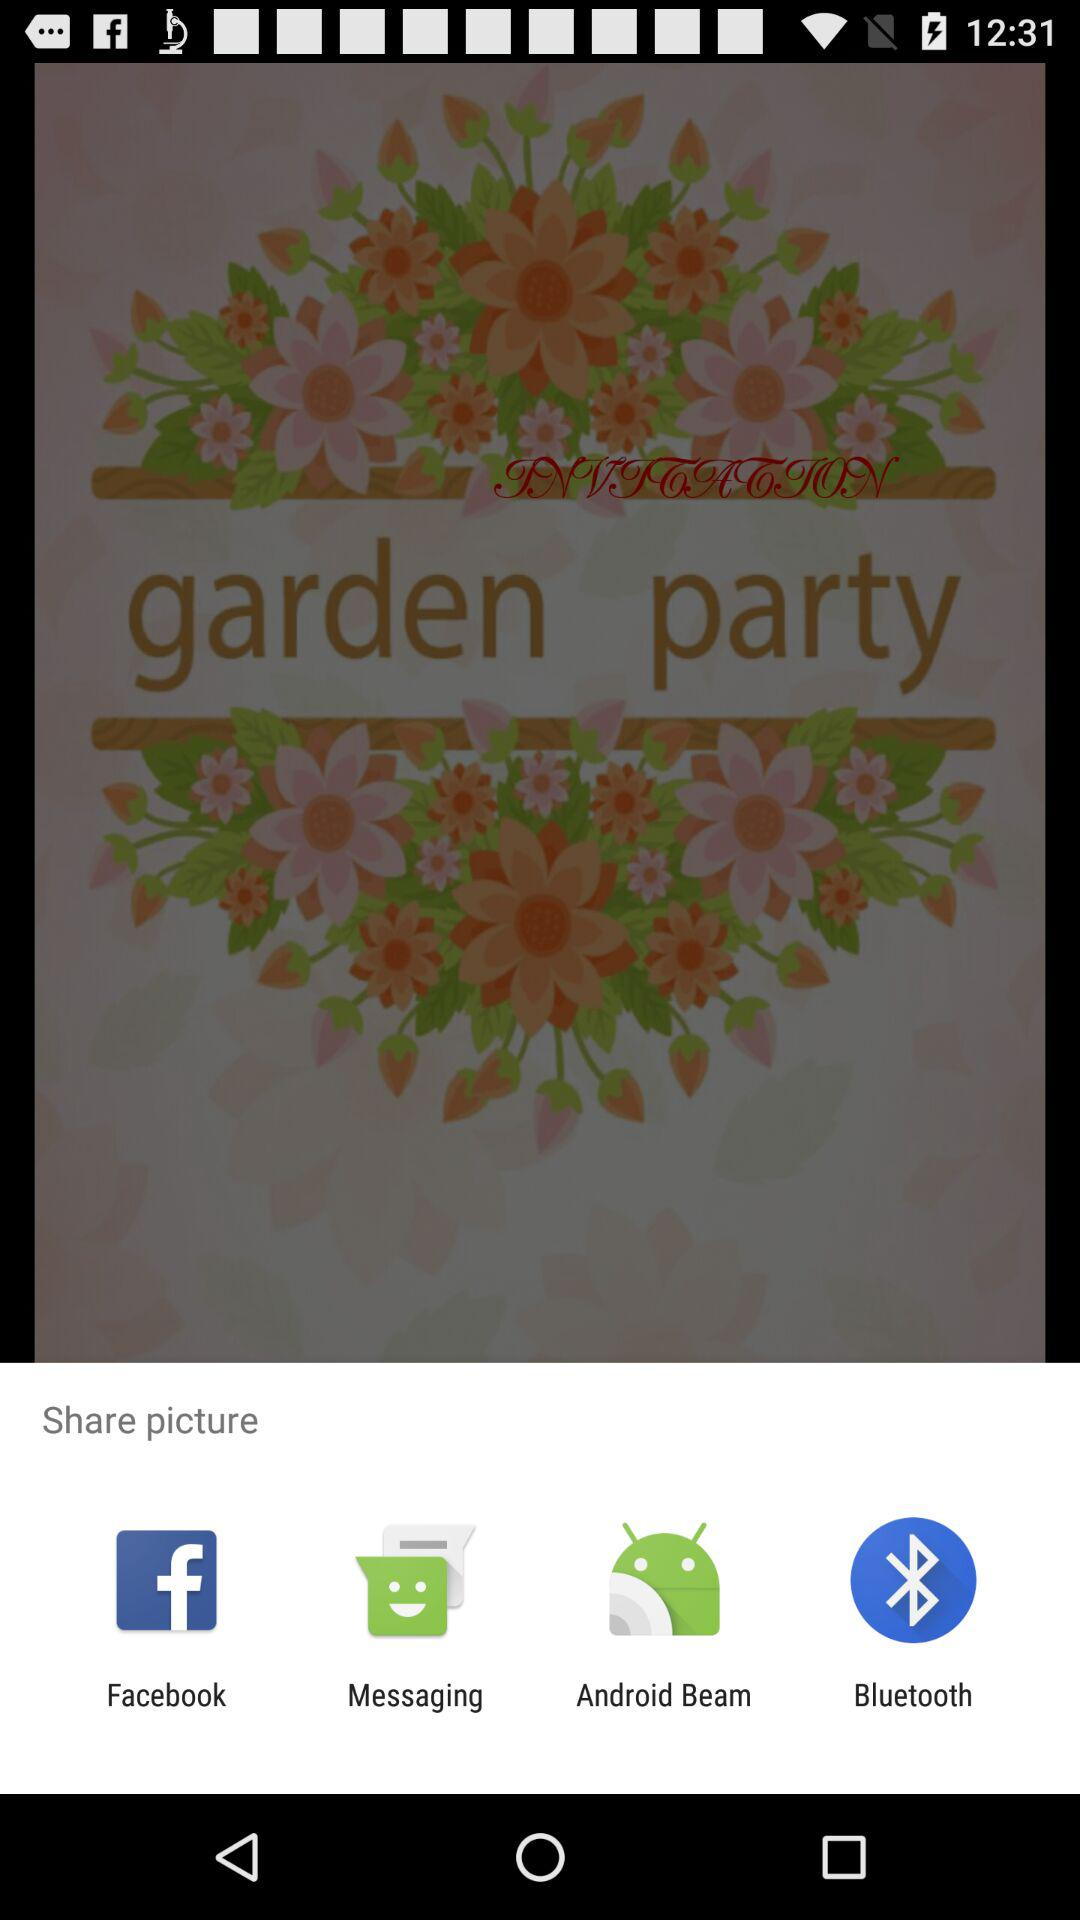What are the sharing options? The sharing options are "Facebook", "Messaging", "Android Beam" and "Bluetooth". 